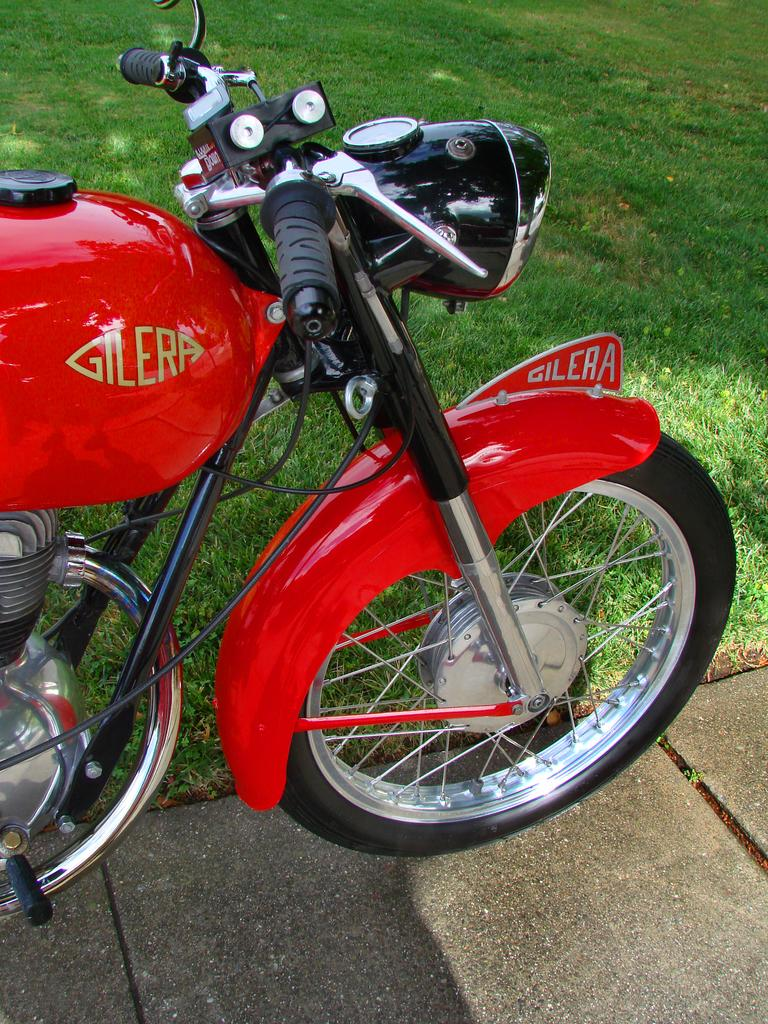What is the main object in the image? There is a bike in the image. What is the position of the bike in the image? The bike is on the ground. What type of environment is visible in the background of the image? There is grass visible in the background of the image. What type of hat is the astronaut wearing in the image? There is no astronaut or hat present in the image; it features a bike on the ground with grass in the background. 